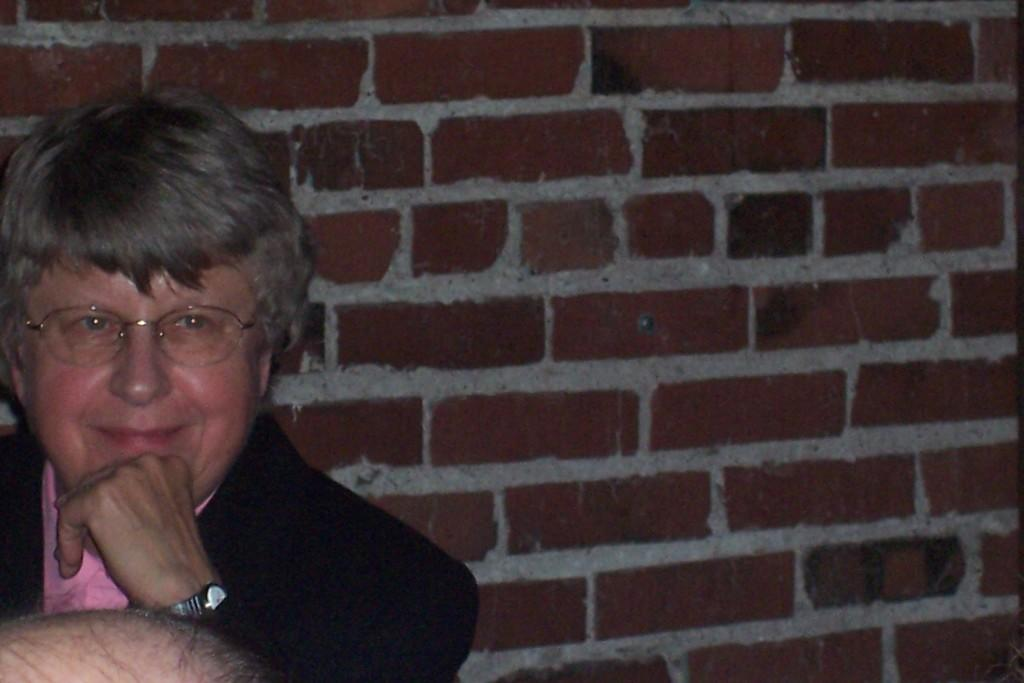What is the person in the image doing? The person in the image is smiling. What can be seen in the background of the image? There is a wall in the background of the image. Where is the person's head located in the image? The person's head is visible at the bottom of the image. What type of arch can be seen in the image? There is no arch present in the image. What material is the quilt made of in the image? There is no quilt present in the image. 